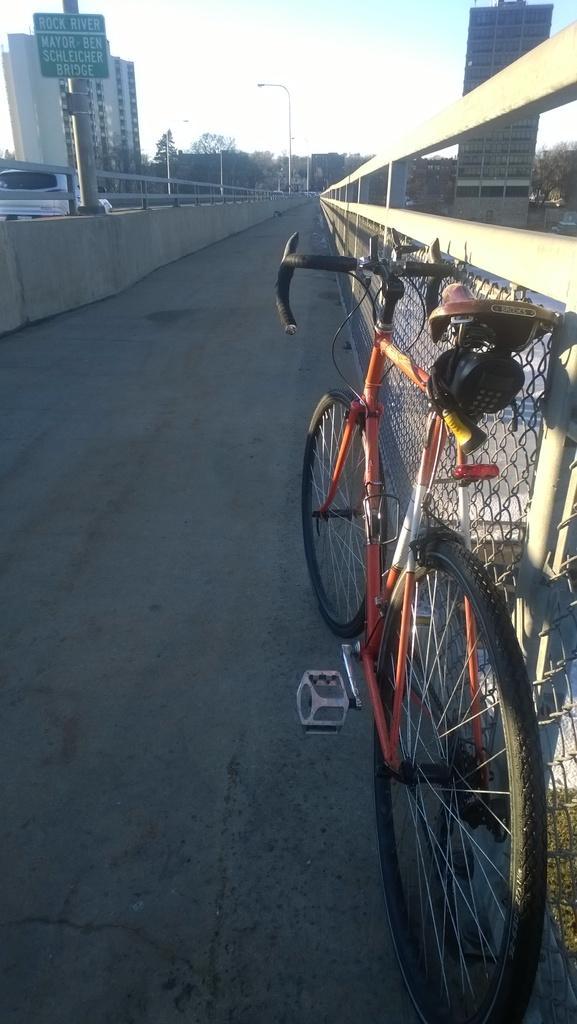Could you give a brief overview of what you see in this image? In this image, we can see a bridge in between buildings. There is a cycle on the bridge. There is a board in the top left of the image. There is a sky at the top of the image. 